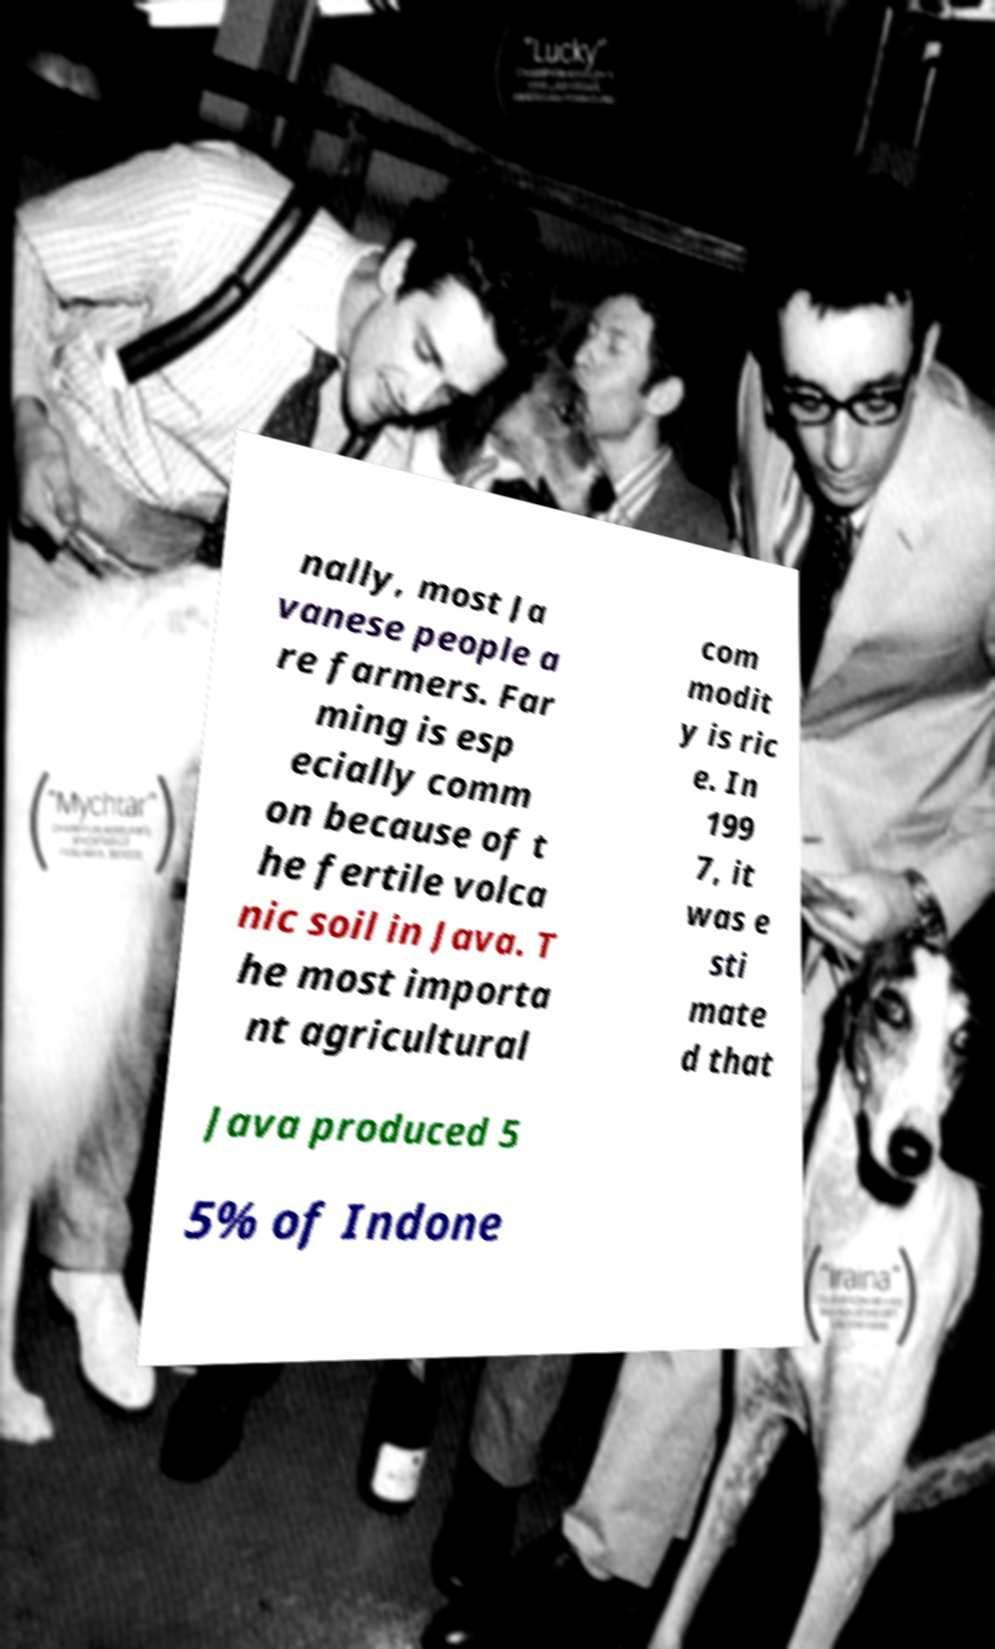Could you extract and type out the text from this image? nally, most Ja vanese people a re farmers. Far ming is esp ecially comm on because of t he fertile volca nic soil in Java. T he most importa nt agricultural com modit y is ric e. In 199 7, it was e sti mate d that Java produced 5 5% of Indone 